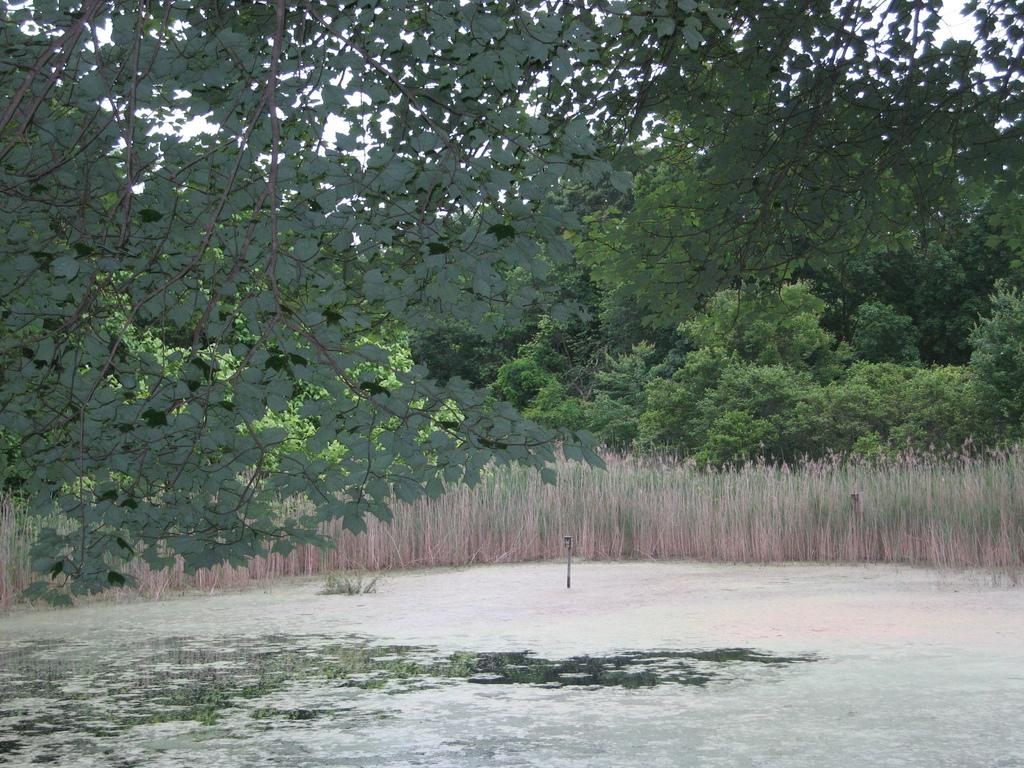What type of vegetation can be seen in the image? There are branches of trees and plants visible in the image. What is the relationship between the branches and the plants? The branches are above the plants, suggesting that they belong to the same or nearby trees. What can be seen in the background of the image? There are plenty of trees visible behind the plants. What type of dress is hanging from the tongue of the tree in the image? There is no dress or tongue present in the image; it features branches of trees and plants. 